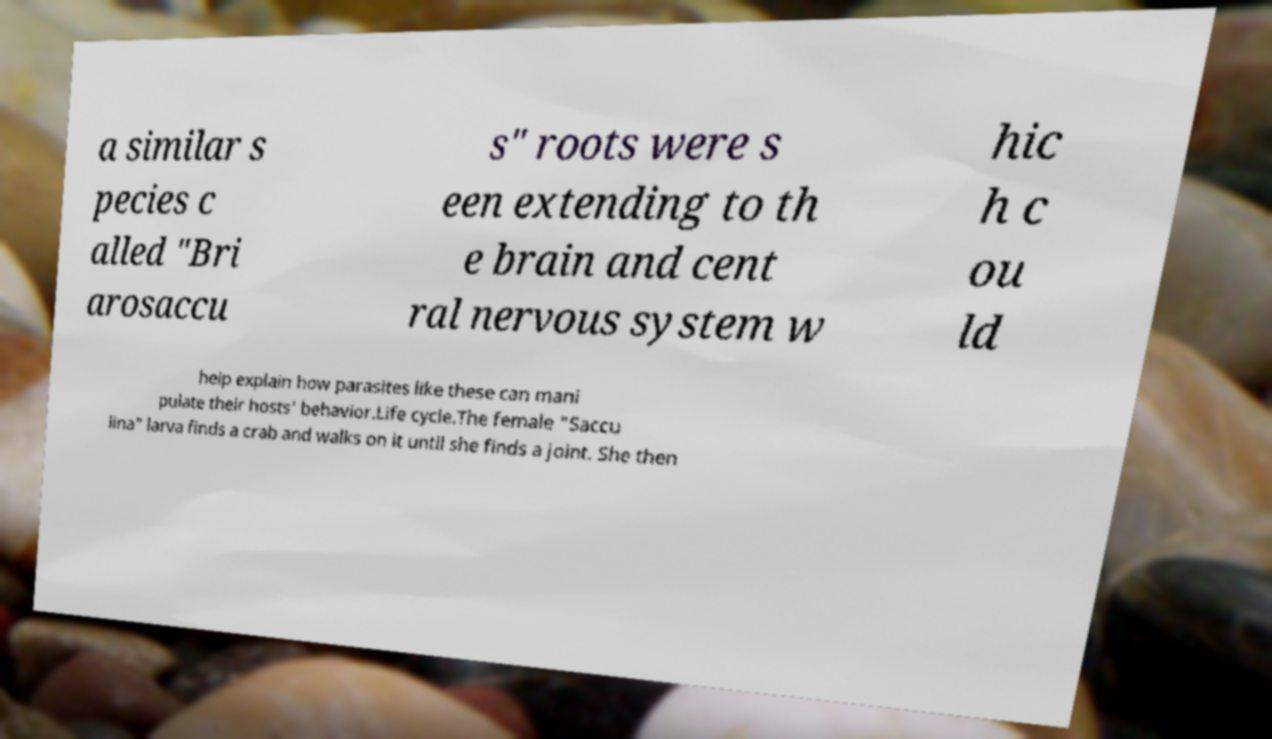Could you extract and type out the text from this image? a similar s pecies c alled "Bri arosaccu s" roots were s een extending to th e brain and cent ral nervous system w hic h c ou ld help explain how parasites like these can mani pulate their hosts' behavior.Life cycle.The female "Saccu lina" larva finds a crab and walks on it until she finds a joint. She then 